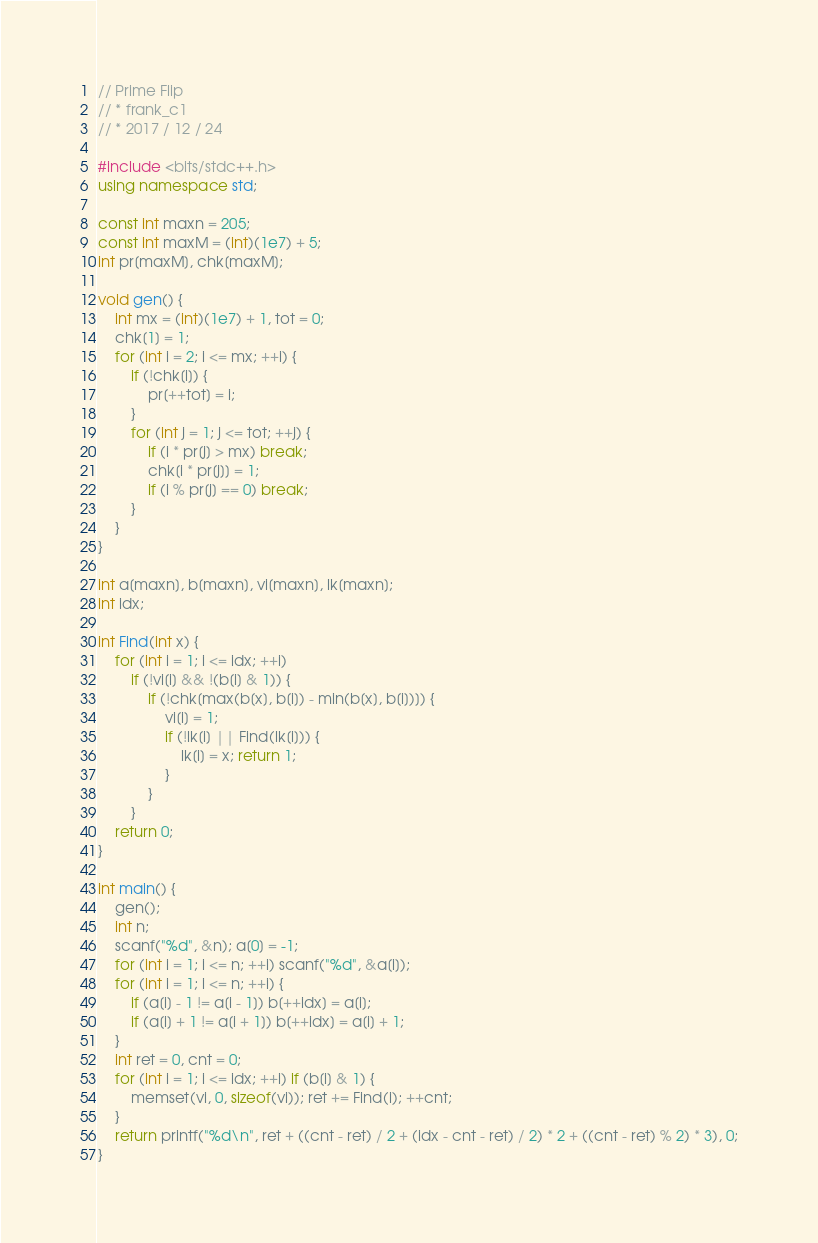Convert code to text. <code><loc_0><loc_0><loc_500><loc_500><_C++_>// Prime Flip
// * frank_c1
// * 2017 / 12 / 24

#include <bits/stdc++.h>
using namespace std;

const int maxn = 205;
const int maxM = (int)(1e7) + 5;
int pr[maxM], chk[maxM];

void gen() {
	int mx = (int)(1e7) + 1, tot = 0;
	chk[1] = 1;
	for (int i = 2; i <= mx; ++i) {
		if (!chk[i]) {
			pr[++tot] = i;
		}
		for (int j = 1; j <= tot; ++j) {
			if (i * pr[j] > mx) break;
			chk[i * pr[j]] = 1;
			if (i % pr[j] == 0) break;
		}
	}
}

int a[maxn], b[maxn], vi[maxn], lk[maxn];
int idx;

int Find(int x) {
	for (int i = 1; i <= idx; ++i) 
		if (!vi[i] && !(b[i] & 1)) {
			if (!chk[max(b[x], b[i]) - min(b[x], b[i])]) {
				vi[i] = 1;
				if (!lk[i] || Find(lk[i])) {
					lk[i] = x; return 1;
				}
			}
		}
	return 0;
}

int main() {
	gen();
	int n;
	scanf("%d", &n); a[0] = -1;
	for (int i = 1; i <= n; ++i) scanf("%d", &a[i]);
	for (int i = 1; i <= n; ++i) {
		if (a[i] - 1 != a[i - 1]) b[++idx] = a[i];
		if (a[i] + 1 != a[i + 1]) b[++idx] = a[i] + 1;
	}
	int ret = 0, cnt = 0;
	for (int i = 1; i <= idx; ++i) if (b[i] & 1) {
		memset(vi, 0, sizeof(vi)); ret += Find(i); ++cnt;
	} 
	return printf("%d\n", ret + ((cnt - ret) / 2 + (idx - cnt - ret) / 2) * 2 + ((cnt - ret) % 2) * 3), 0;
}</code> 